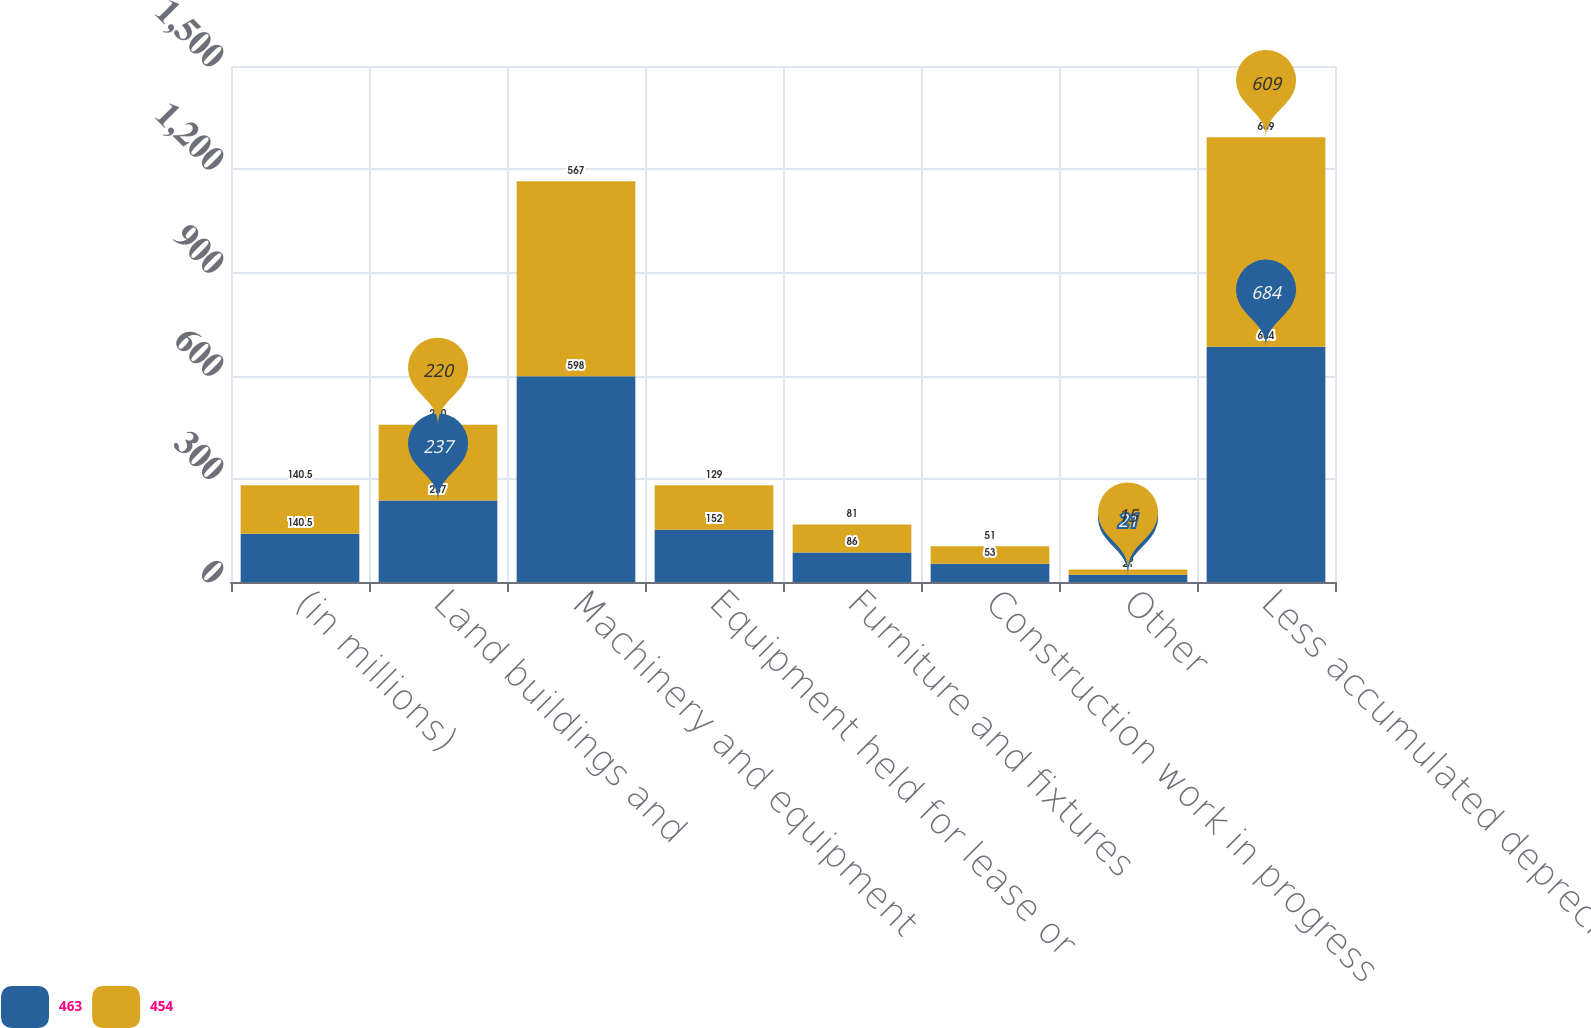Convert chart. <chart><loc_0><loc_0><loc_500><loc_500><stacked_bar_chart><ecel><fcel>(in millions)<fcel>Land buildings and<fcel>Machinery and equipment<fcel>Equipment held for lease or<fcel>Furniture and fixtures<fcel>Construction work in progress<fcel>Other<fcel>Less accumulated depreciation<nl><fcel>463<fcel>140.5<fcel>237<fcel>598<fcel>152<fcel>86<fcel>53<fcel>21<fcel>684<nl><fcel>454<fcel>140.5<fcel>220<fcel>567<fcel>129<fcel>81<fcel>51<fcel>15<fcel>609<nl></chart> 